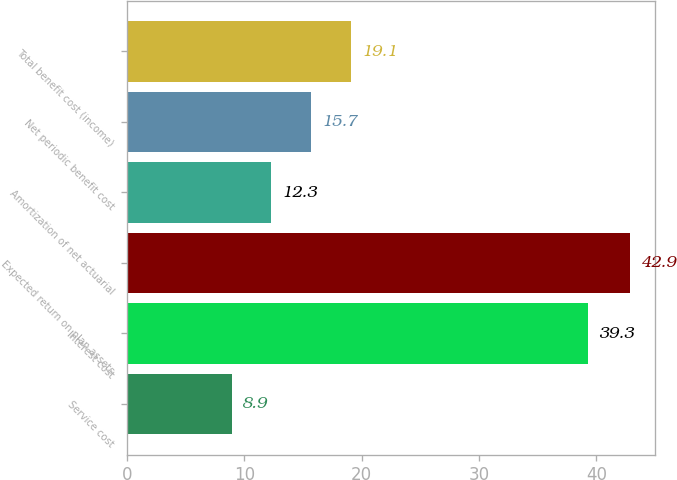<chart> <loc_0><loc_0><loc_500><loc_500><bar_chart><fcel>Service cost<fcel>Interest cost<fcel>Expected return on plan assets<fcel>Amortization of net actuarial<fcel>Net periodic benefit cost<fcel>Total benefit cost (income)<nl><fcel>8.9<fcel>39.3<fcel>42.9<fcel>12.3<fcel>15.7<fcel>19.1<nl></chart> 